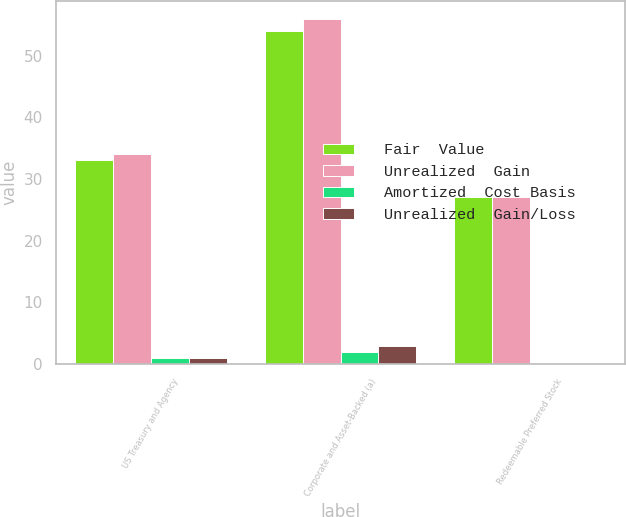<chart> <loc_0><loc_0><loc_500><loc_500><stacked_bar_chart><ecel><fcel>US Treasury and Agency<fcel>Corporate and Asset-Backed (a)<fcel>Redeemable Preferred Stock<nl><fcel>Fair  Value<fcel>33<fcel>54<fcel>27<nl><fcel>Unrealized  Gain<fcel>34<fcel>56<fcel>27<nl><fcel>Amortized  Cost Basis<fcel>1<fcel>2<fcel>0<nl><fcel>Unrealized  Gain/Loss<fcel>1<fcel>3<fcel>0<nl></chart> 